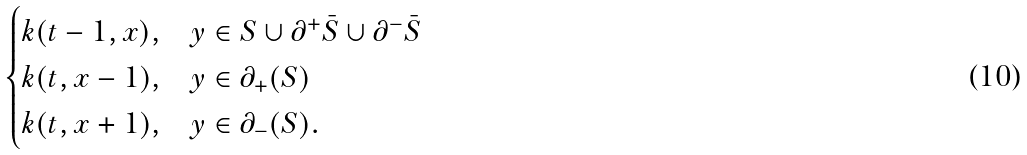<formula> <loc_0><loc_0><loc_500><loc_500>\begin{cases} k ( t - 1 , x ) , & y \in S \cup \partial ^ { + } \bar { S } \cup \partial ^ { - } \bar { S } \\ k ( t , x - 1 ) , & y \in \partial _ { + } ( S ) \\ k ( t , x + 1 ) , & y \in \partial _ { - } ( S ) . \end{cases}</formula> 